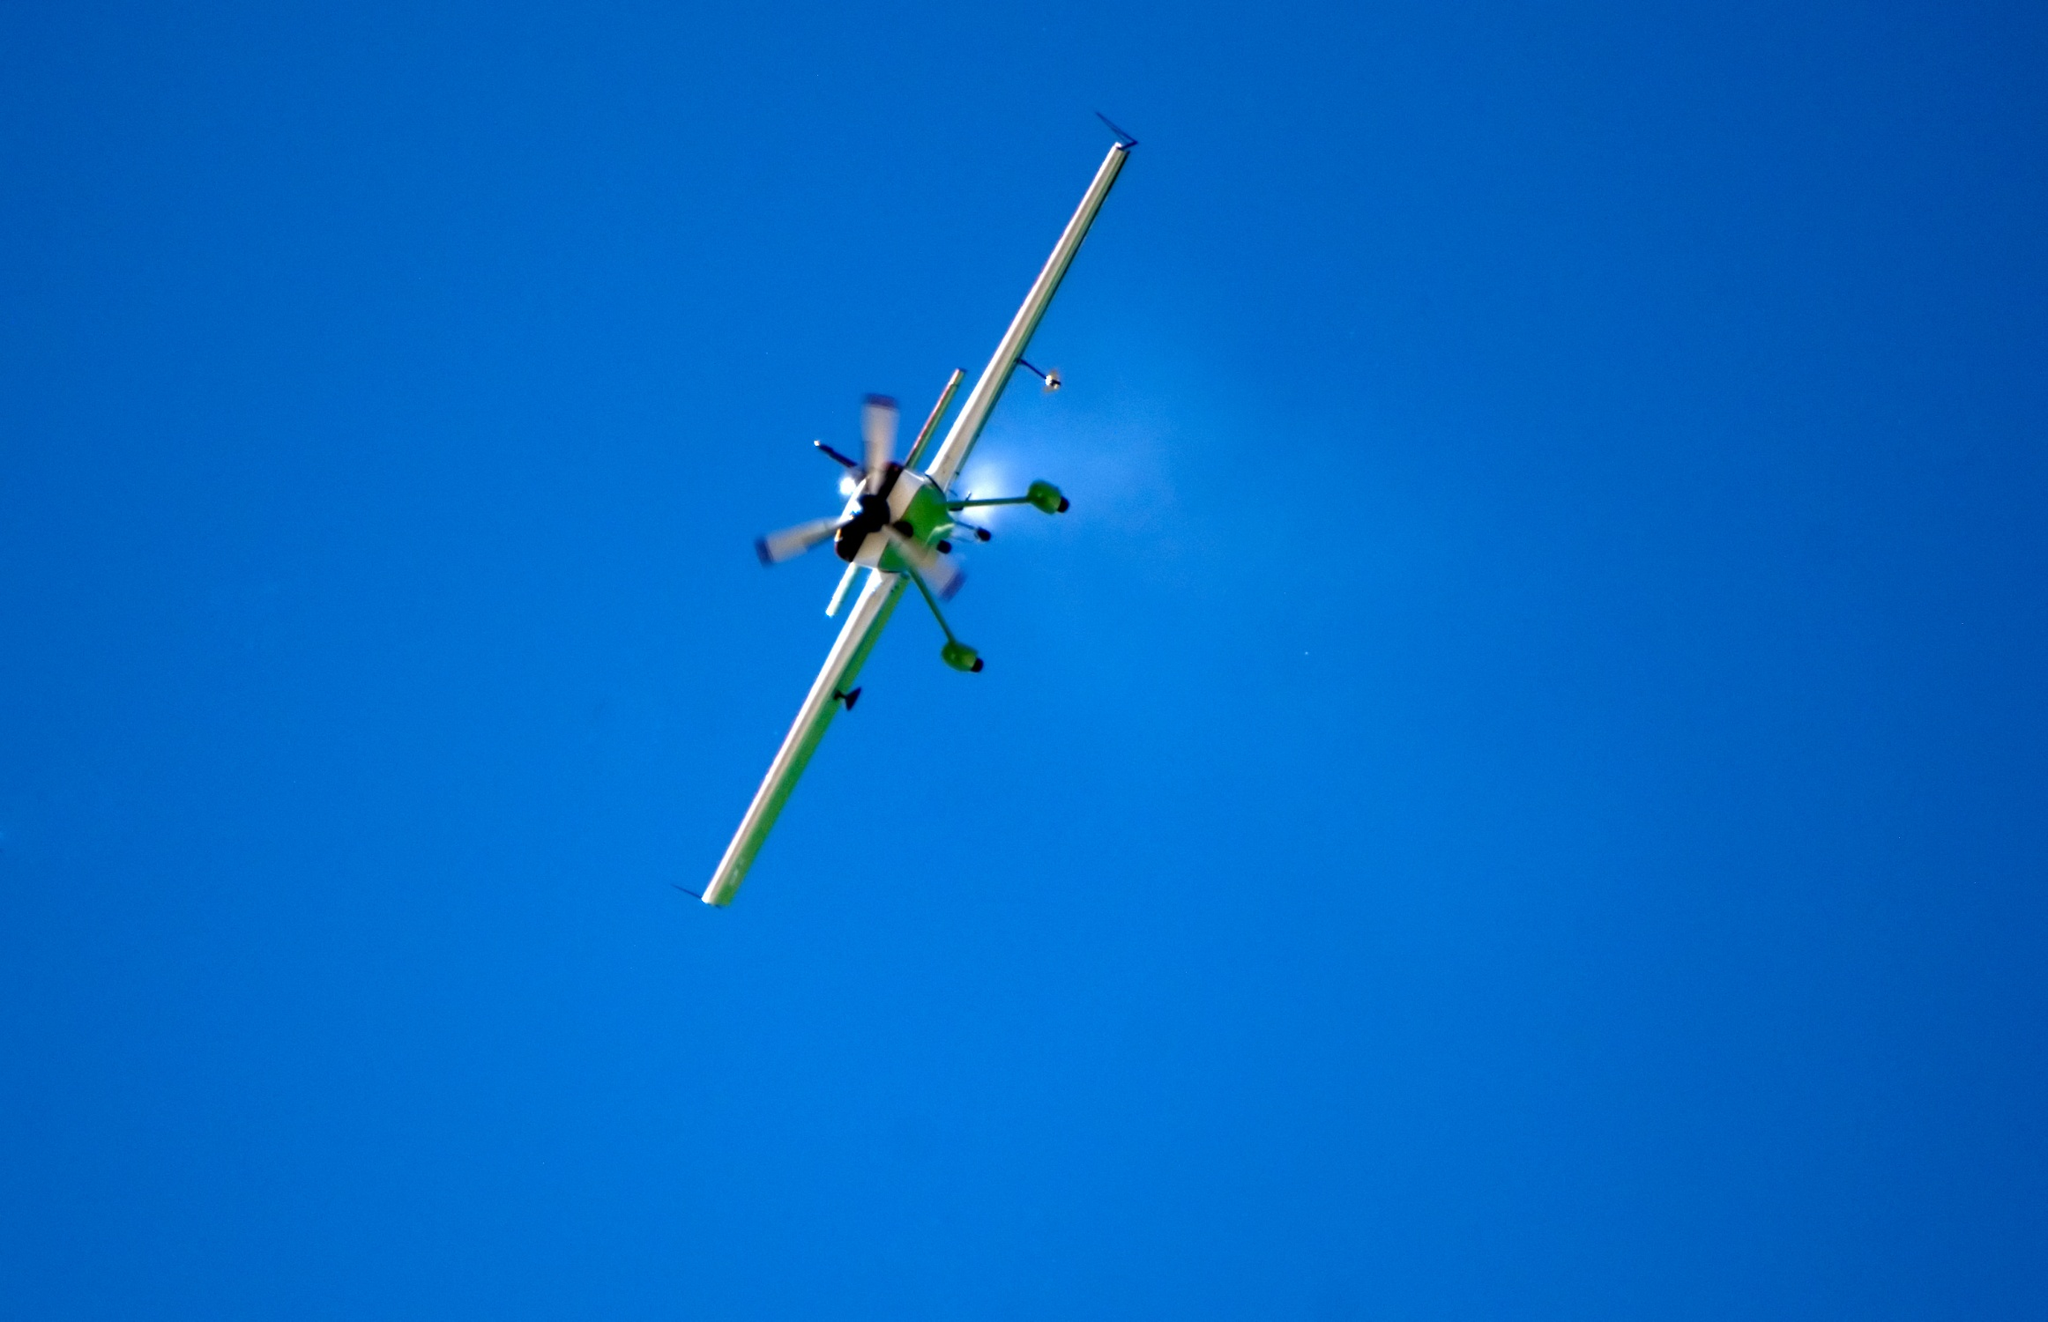What type of airplane is shown in the image? The airplane in the image is a small propeller-driven aircraft, likely used for personal or recreational purposes. Its compact design and single propeller setup suggest it's engineered for agility and is well-suited for short flights. 